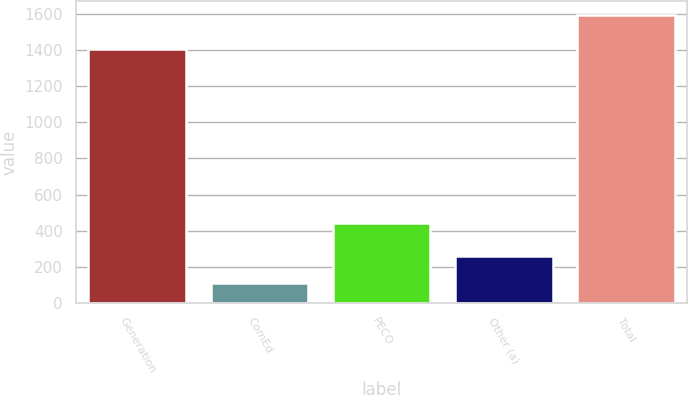Convert chart. <chart><loc_0><loc_0><loc_500><loc_500><bar_chart><fcel>Generation<fcel>ComEd<fcel>PECO<fcel>Other (a)<fcel>Total<nl><fcel>1407<fcel>112<fcel>441<fcel>260<fcel>1592<nl></chart> 